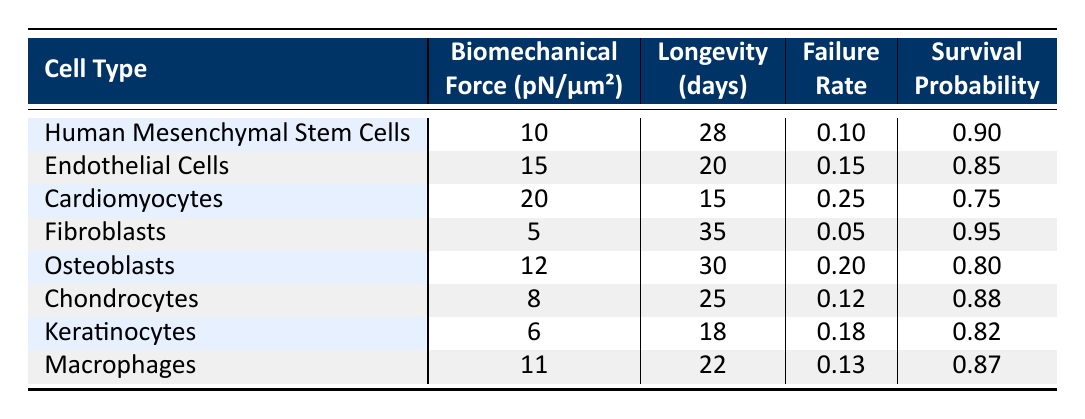What is the longevity of Fibroblasts under biomechanical force of 5 pN/μm²? The table shows that for Fibroblasts, the longevity under a biomechanical force of 5 pN/μm² is listed as 35 days.
Answer: 35 days Which cell type has the highest failure rate? By examining the failure rate column, Cardiomyocytes have the highest failure rate at 0.25, while all other cell types have lower rates.
Answer: Cardiomyocytes What is the average longevity of the cell types exposed to biomechanical forces? First, we sum the longevity values: 28 + 20 + 15 + 35 + 30 + 25 + 18 + 22 = 173 days. There are eight cell types, so we divide by 8: 173/8 = 21.625 days.
Answer: 21.625 days Is the failure rate of Endothelial Cells greater than that of Osteoblasts? The failure rate for Endothelial Cells is 0.15 and for Osteoblasts is 0.20. Since 0.15 is less than 0.20, this statement is false.
Answer: No What is the difference in longevity between the cell types with the highest and lowest longevity? The highest longevity is 35 days (Fibroblasts), and the lowest is 15 days (Cardiomyocytes). Therefore, the difference is 35 - 15 = 20 days.
Answer: 20 days Which biomechanical force corresponds to Macrophages? From the table, the respective biomechanical force for Macrophages is 11 pN/μm².
Answer: 11 pN/μm² Are Keratinocytes longer-lived than Endothelial Cells? The longevity of Keratinocytes is 18 days, and for Endothelial Cells, it is 20 days. Since 18 is less than 20, this statement is false.
Answer: No What is the survival probability of Human Mesenchymal Stem Cells? The table indicates that the survival probability for Human Mesenchymal Stem Cells is 0.90.
Answer: 0.90 Which cell type has a longevity exactly between that of Chondrocytes and Cardiomyocytes? Chondrocytes have a longevity of 25 days and Cardiomyocytes have 15 days. The average is (25 + 15)/2 = 20 days. The cell type that matches this longevity is Endothelial Cells, which lasts 20 days.
Answer: Endothelial Cells 